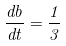<formula> <loc_0><loc_0><loc_500><loc_500>\frac { d b } { d t } = \frac { 1 } { 3 }</formula> 